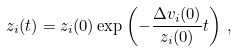<formula> <loc_0><loc_0><loc_500><loc_500>z _ { i } ( t ) = z _ { i } ( 0 ) \exp \left ( - \frac { \Delta v _ { i } ( 0 ) } { z _ { i } ( 0 ) } t \right ) \, ,</formula> 